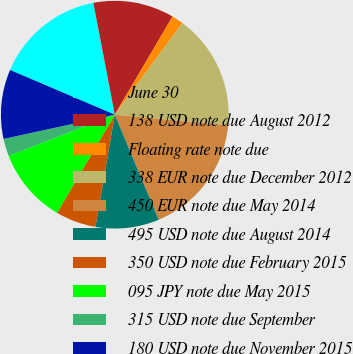Convert chart. <chart><loc_0><loc_0><loc_500><loc_500><pie_chart><fcel>June 30<fcel>138 USD note due August 2012<fcel>Floating rate note due<fcel>338 EUR note due December 2012<fcel>450 EUR note due May 2014<fcel>495 USD note due August 2014<fcel>350 USD note due February 2015<fcel>095 JPY note due May 2015<fcel>315 USD note due September<fcel>180 USD note due November 2015<nl><fcel>15.57%<fcel>11.48%<fcel>1.64%<fcel>16.39%<fcel>17.21%<fcel>9.02%<fcel>5.74%<fcel>10.66%<fcel>2.46%<fcel>9.84%<nl></chart> 